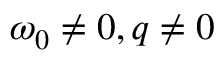Convert formula to latex. <formula><loc_0><loc_0><loc_500><loc_500>\omega _ { 0 } \ne 0 , q \ne 0</formula> 